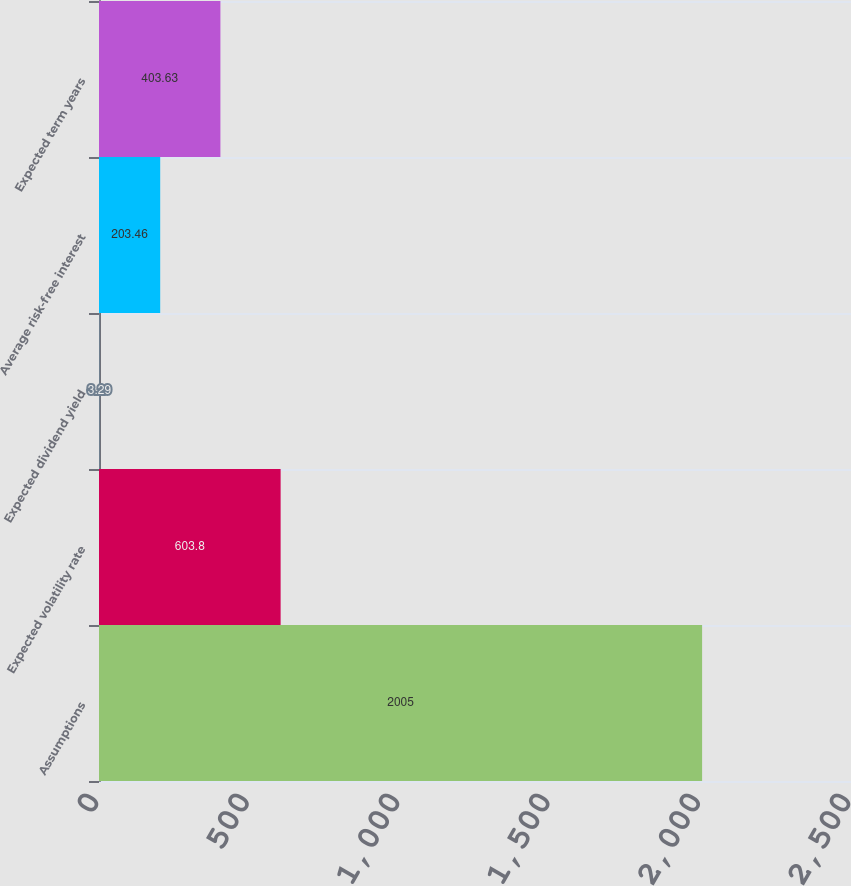Convert chart to OTSL. <chart><loc_0><loc_0><loc_500><loc_500><bar_chart><fcel>Assumptions<fcel>Expected volatility rate<fcel>Expected dividend yield<fcel>Average risk-free interest<fcel>Expected term years<nl><fcel>2005<fcel>603.8<fcel>3.29<fcel>203.46<fcel>403.63<nl></chart> 